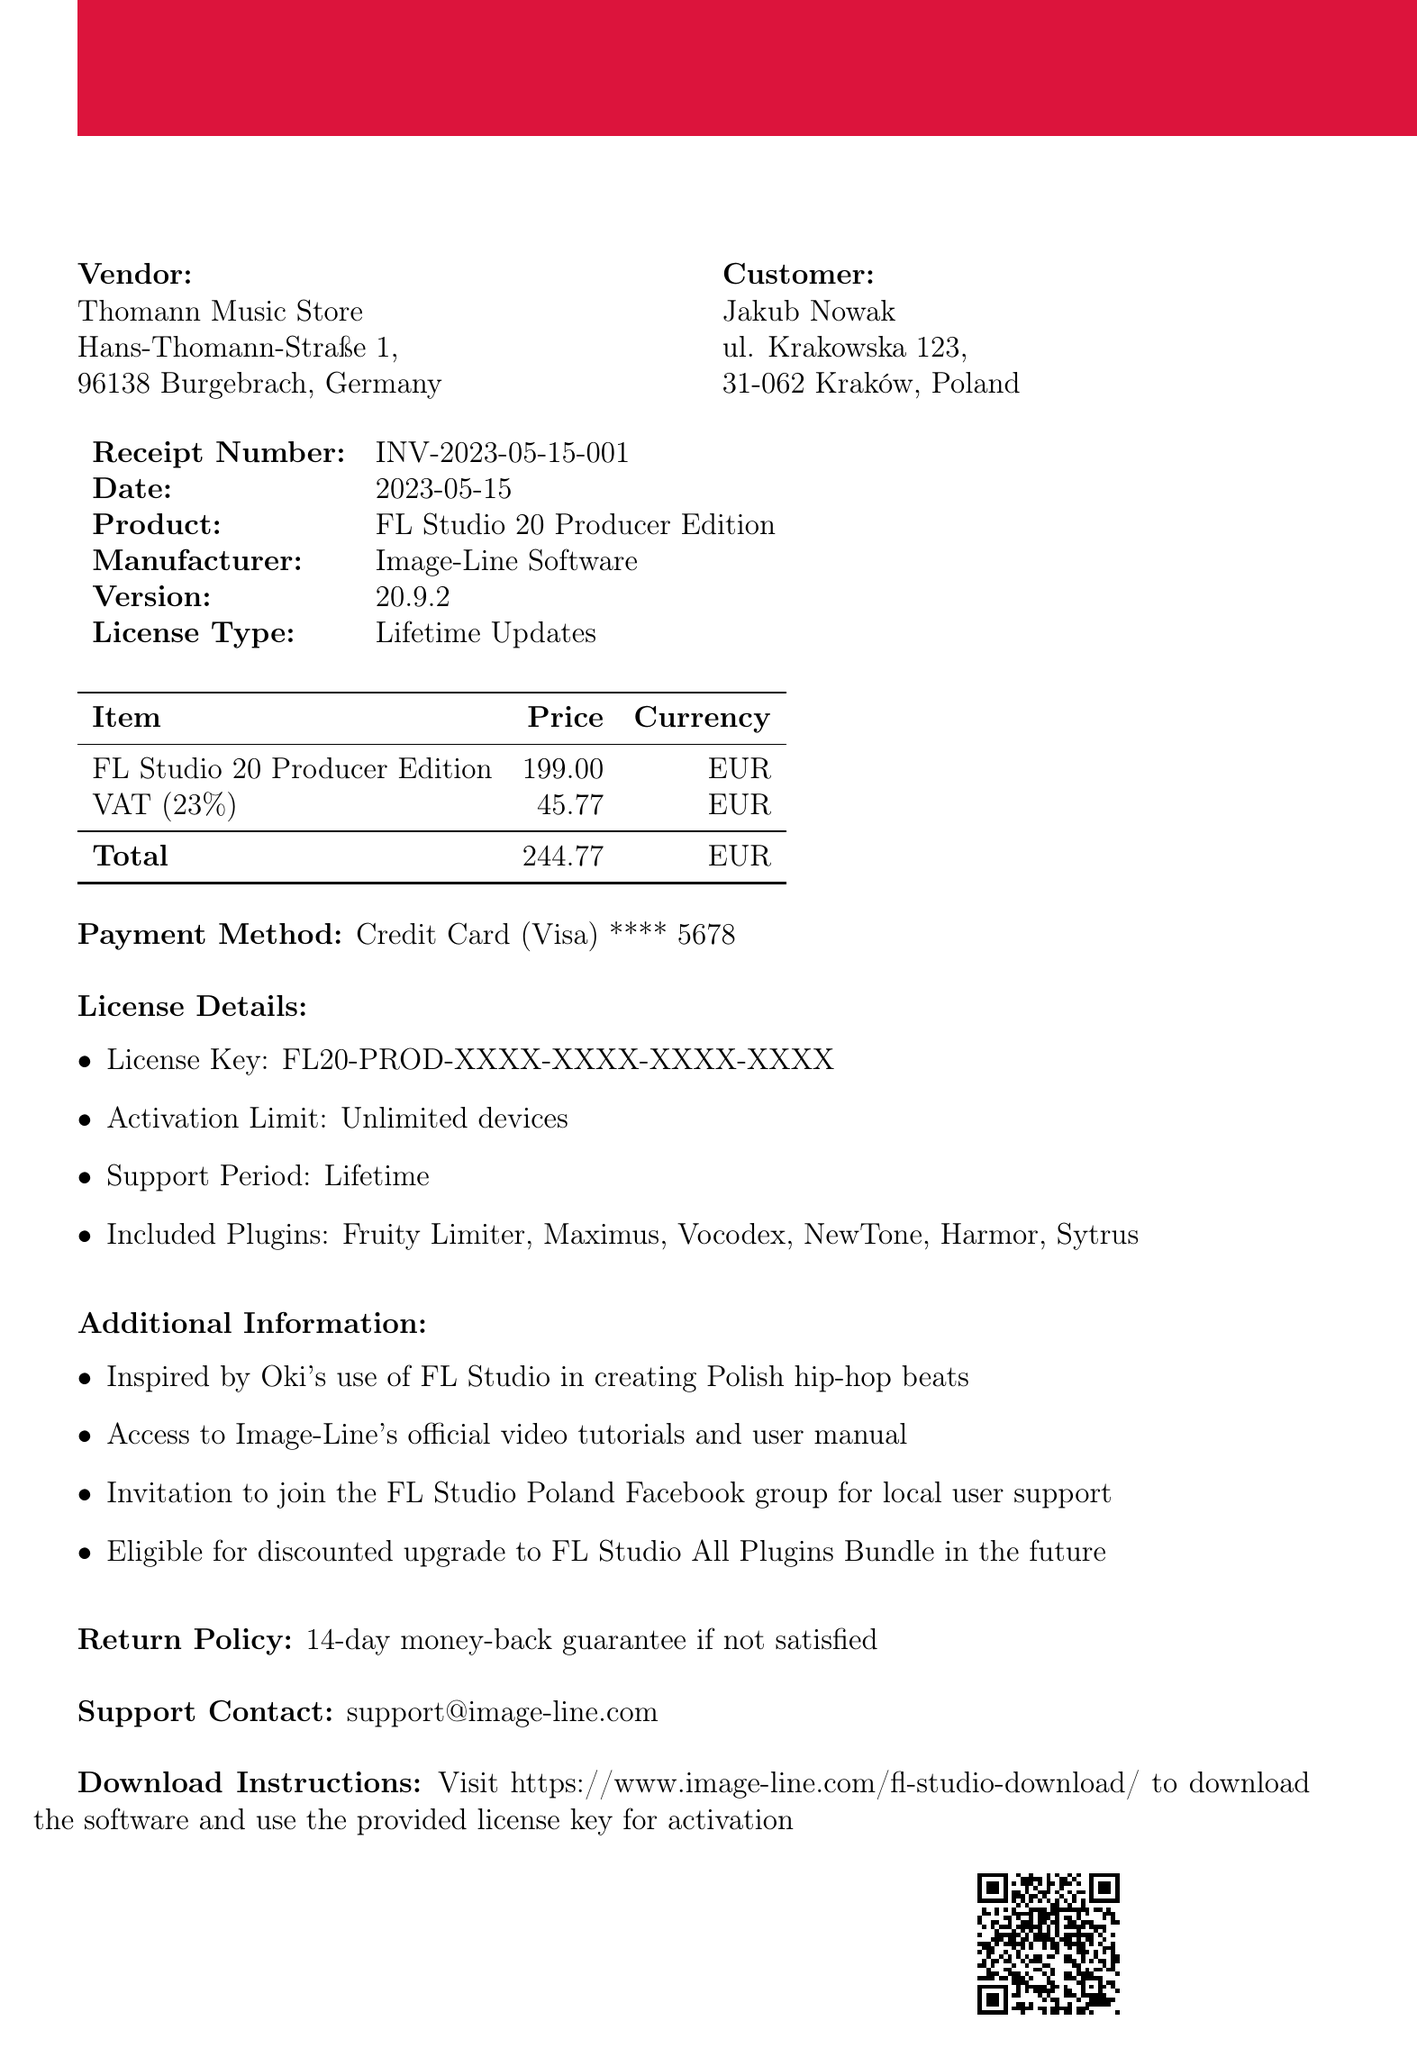What is the receipt number? The receipt number is specified at the beginning of the document as a unique identifier for the transaction.
Answer: INV-2023-05-15-001 What is the date of the purchase? The date field clearly indicates when the transaction occurred.
Answer: 2023-05-15 Who is the vendor? The vendor is the entity from which the software was purchased, as shown in the document.
Answer: Thomann Music Store What is the total amount paid? The total amount is calculated by adding the price of the product and VAT, which is displayed in the cost breakdown.
Answer: 244.77 What type of license is included? The license type is specified in the document and indicates the support and update terms for the software.
Answer: Lifetime Updates How many plugins are included? The document lists the included plugins under license details, which indicates the features available with the purchase.
Answer: Six What is the return policy? The return policy describes the conditions under which the customer can request a refund.
Answer: 14-day money-back guarantee if not satisfied What is the support contact email? The support contact gives the information for customer service help related to the purchased software.
Answer: support@image-line.com What is the payment method used? The payment method indicates how the transaction was completed, which is also listed in the document.
Answer: Credit Card (Visa) 